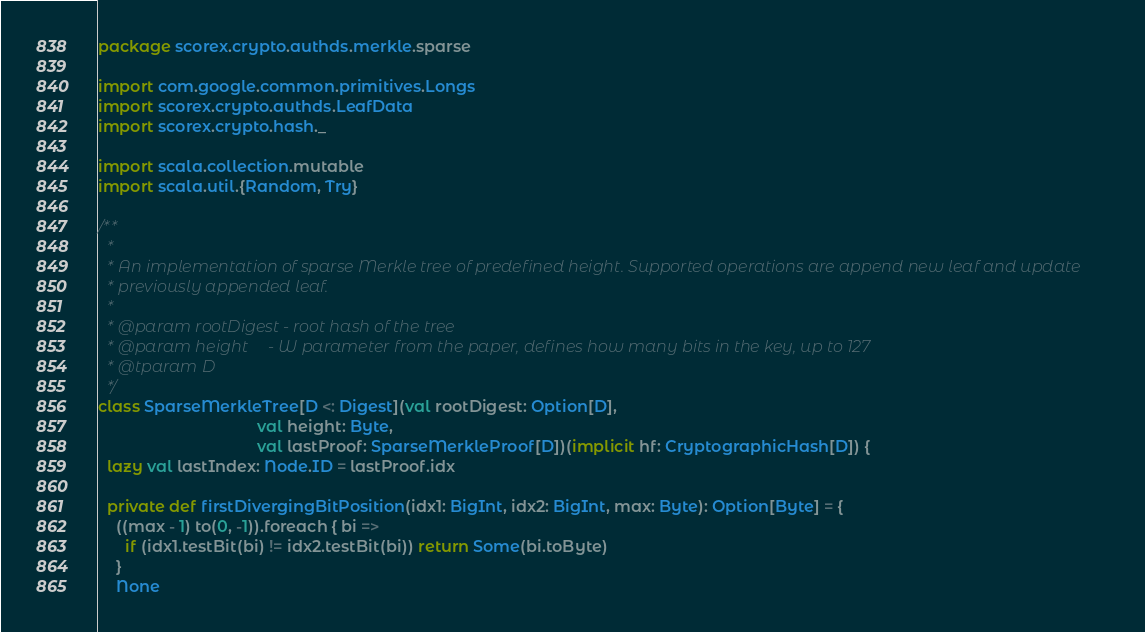Convert code to text. <code><loc_0><loc_0><loc_500><loc_500><_Scala_>package scorex.crypto.authds.merkle.sparse

import com.google.common.primitives.Longs
import scorex.crypto.authds.LeafData
import scorex.crypto.hash._

import scala.collection.mutable
import scala.util.{Random, Try}

/**
  *
  * An implementation of sparse Merkle tree of predefined height. Supported operations are append new leaf and update
  * previously appended leaf.
  *
  * @param rootDigest - root hash of the tree
  * @param height     - W parameter from the paper, defines how many bits in the key, up to 127
  * @tparam D
  */
class SparseMerkleTree[D <: Digest](val rootDigest: Option[D],
                                    val height: Byte,
                                    val lastProof: SparseMerkleProof[D])(implicit hf: CryptographicHash[D]) {
  lazy val lastIndex: Node.ID = lastProof.idx

  private def firstDivergingBitPosition(idx1: BigInt, idx2: BigInt, max: Byte): Option[Byte] = {
    ((max - 1) to(0, -1)).foreach { bi =>
      if (idx1.testBit(bi) != idx2.testBit(bi)) return Some(bi.toByte)
    }
    None</code> 